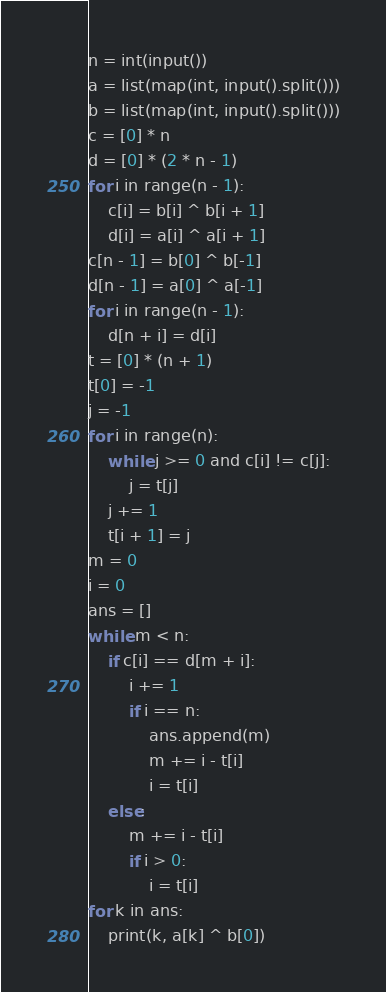Convert code to text. <code><loc_0><loc_0><loc_500><loc_500><_Python_>n = int(input())
a = list(map(int, input().split()))
b = list(map(int, input().split()))
c = [0] * n
d = [0] * (2 * n - 1)
for i in range(n - 1):
    c[i] = b[i] ^ b[i + 1]
    d[i] = a[i] ^ a[i + 1]
c[n - 1] = b[0] ^ b[-1]
d[n - 1] = a[0] ^ a[-1]
for i in range(n - 1):
    d[n + i] = d[i]
t = [0] * (n + 1)
t[0] = -1
j = -1
for i in range(n):
    while j >= 0 and c[i] != c[j]:
        j = t[j]
    j += 1
    t[i + 1] = j
m = 0
i = 0
ans = []
while m < n:
    if c[i] == d[m + i]:
        i += 1
        if i == n:
            ans.append(m)
            m += i - t[i]
            i = t[i]
    else:
        m += i - t[i]
        if i > 0:
            i = t[i]
for k in ans:
    print(k, a[k] ^ b[0])
</code> 